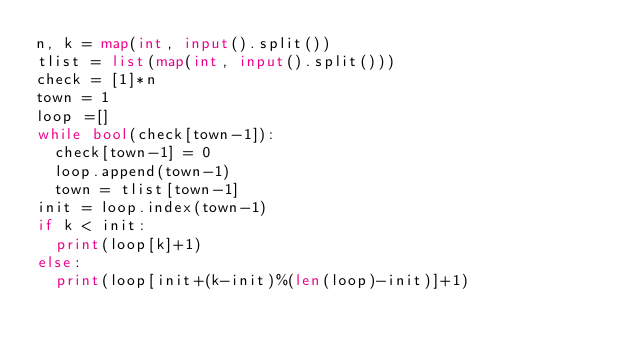Convert code to text. <code><loc_0><loc_0><loc_500><loc_500><_Python_>n, k = map(int, input().split())
tlist = list(map(int, input().split()))
check = [1]*n
town = 1
loop =[]
while bool(check[town-1]):
  check[town-1] = 0
  loop.append(town-1)
  town = tlist[town-1]
init = loop.index(town-1)
if k < init:
  print(loop[k]+1)
else:
  print(loop[init+(k-init)%(len(loop)-init)]+1)</code> 